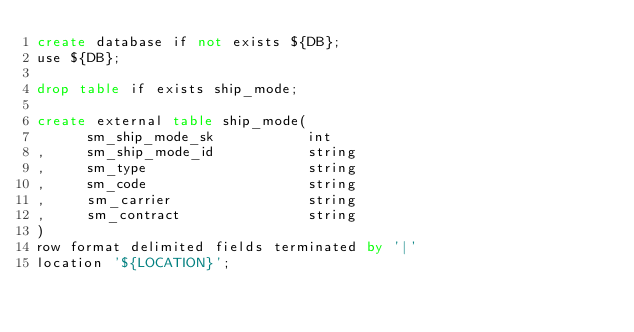<code> <loc_0><loc_0><loc_500><loc_500><_SQL_>create database if not exists ${DB};
use ${DB};

drop table if exists ship_mode;

create external table ship_mode(
      sm_ship_mode_sk           int               
,     sm_ship_mode_id           string              
,     sm_type                   string                      
,     sm_code                   string                      
,     sm_carrier                string                      
,     sm_contract               string                      
)
row format delimited fields terminated by '|' 
location '${LOCATION}';
</code> 